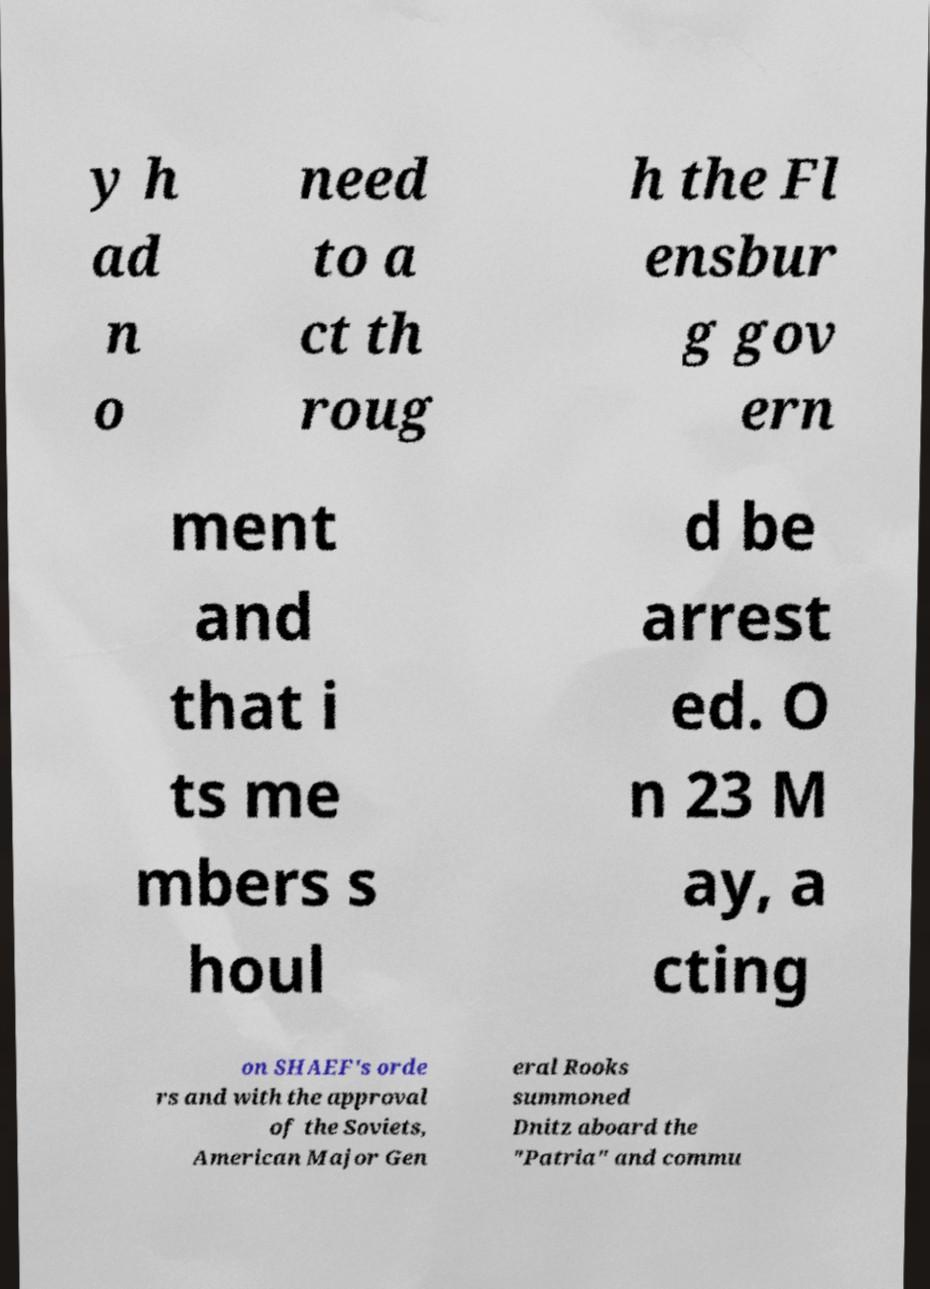For documentation purposes, I need the text within this image transcribed. Could you provide that? y h ad n o need to a ct th roug h the Fl ensbur g gov ern ment and that i ts me mbers s houl d be arrest ed. O n 23 M ay, a cting on SHAEF's orde rs and with the approval of the Soviets, American Major Gen eral Rooks summoned Dnitz aboard the "Patria" and commu 